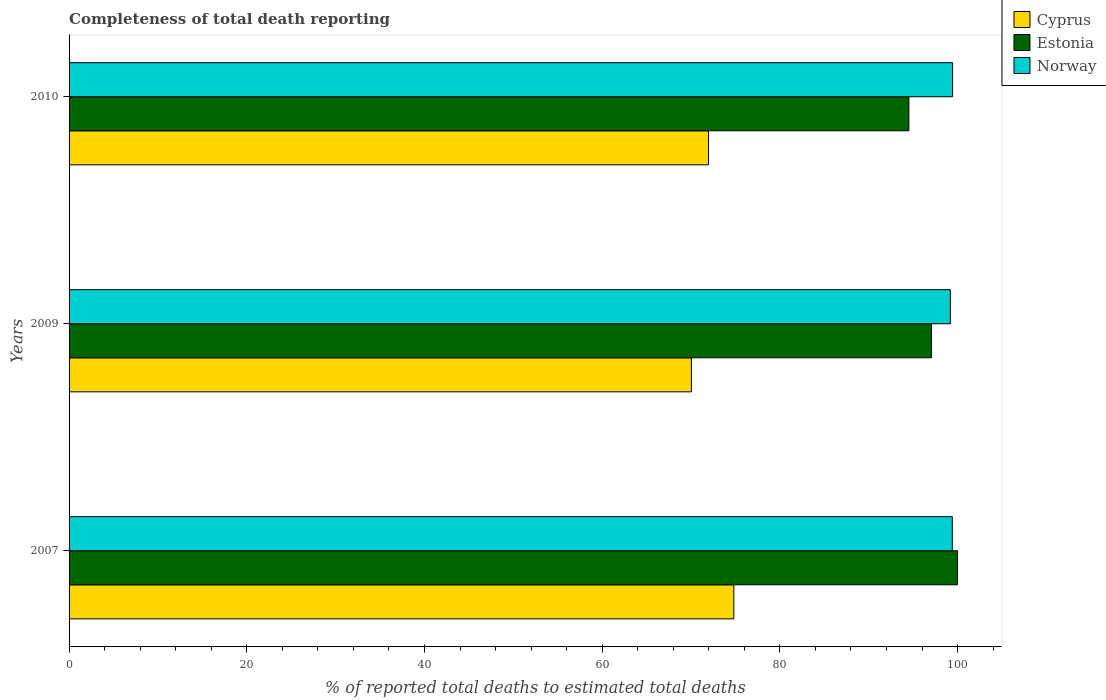How many groups of bars are there?
Your response must be concise. 3. In how many cases, is the number of bars for a given year not equal to the number of legend labels?
Keep it short and to the point. 0. What is the percentage of total deaths reported in Norway in 2010?
Give a very brief answer. 99.44. Across all years, what is the maximum percentage of total deaths reported in Estonia?
Your answer should be very brief. 100. Across all years, what is the minimum percentage of total deaths reported in Norway?
Offer a terse response. 99.19. In which year was the percentage of total deaths reported in Cyprus maximum?
Your response must be concise. 2007. In which year was the percentage of total deaths reported in Norway minimum?
Make the answer very short. 2009. What is the total percentage of total deaths reported in Norway in the graph?
Keep it short and to the point. 298.04. What is the difference between the percentage of total deaths reported in Estonia in 2007 and that in 2009?
Your answer should be very brief. 2.94. What is the difference between the percentage of total deaths reported in Cyprus in 2010 and the percentage of total deaths reported in Estonia in 2007?
Your response must be concise. -28.03. What is the average percentage of total deaths reported in Estonia per year?
Offer a terse response. 97.19. In the year 2007, what is the difference between the percentage of total deaths reported in Norway and percentage of total deaths reported in Estonia?
Ensure brevity in your answer.  -0.59. What is the ratio of the percentage of total deaths reported in Estonia in 2007 to that in 2010?
Make the answer very short. 1.06. Is the percentage of total deaths reported in Norway in 2007 less than that in 2009?
Offer a very short reply. No. Is the difference between the percentage of total deaths reported in Norway in 2007 and 2009 greater than the difference between the percentage of total deaths reported in Estonia in 2007 and 2009?
Provide a short and direct response. No. What is the difference between the highest and the second highest percentage of total deaths reported in Norway?
Provide a short and direct response. 0.03. What is the difference between the highest and the lowest percentage of total deaths reported in Norway?
Ensure brevity in your answer.  0.25. What does the 3rd bar from the top in 2009 represents?
Provide a short and direct response. Cyprus. What does the 1st bar from the bottom in 2009 represents?
Make the answer very short. Cyprus. Is it the case that in every year, the sum of the percentage of total deaths reported in Norway and percentage of total deaths reported in Cyprus is greater than the percentage of total deaths reported in Estonia?
Keep it short and to the point. Yes. How many bars are there?
Keep it short and to the point. 9. Are all the bars in the graph horizontal?
Your response must be concise. Yes. How many years are there in the graph?
Give a very brief answer. 3. What is the difference between two consecutive major ticks on the X-axis?
Your answer should be compact. 20. Does the graph contain any zero values?
Your answer should be very brief. No. Where does the legend appear in the graph?
Give a very brief answer. Top right. What is the title of the graph?
Provide a short and direct response. Completeness of total death reporting. What is the label or title of the X-axis?
Ensure brevity in your answer.  % of reported total deaths to estimated total deaths. What is the % of reported total deaths to estimated total deaths of Cyprus in 2007?
Provide a succinct answer. 74.82. What is the % of reported total deaths to estimated total deaths in Norway in 2007?
Your answer should be very brief. 99.41. What is the % of reported total deaths to estimated total deaths of Cyprus in 2009?
Ensure brevity in your answer.  70.05. What is the % of reported total deaths to estimated total deaths in Estonia in 2009?
Offer a very short reply. 97.06. What is the % of reported total deaths to estimated total deaths of Norway in 2009?
Provide a short and direct response. 99.19. What is the % of reported total deaths to estimated total deaths of Cyprus in 2010?
Provide a succinct answer. 71.97. What is the % of reported total deaths to estimated total deaths of Estonia in 2010?
Offer a terse response. 94.52. What is the % of reported total deaths to estimated total deaths of Norway in 2010?
Provide a short and direct response. 99.44. Across all years, what is the maximum % of reported total deaths to estimated total deaths of Cyprus?
Provide a succinct answer. 74.82. Across all years, what is the maximum % of reported total deaths to estimated total deaths in Norway?
Offer a very short reply. 99.44. Across all years, what is the minimum % of reported total deaths to estimated total deaths of Cyprus?
Provide a succinct answer. 70.05. Across all years, what is the minimum % of reported total deaths to estimated total deaths in Estonia?
Offer a very short reply. 94.52. Across all years, what is the minimum % of reported total deaths to estimated total deaths of Norway?
Provide a short and direct response. 99.19. What is the total % of reported total deaths to estimated total deaths of Cyprus in the graph?
Your answer should be compact. 216.84. What is the total % of reported total deaths to estimated total deaths of Estonia in the graph?
Provide a short and direct response. 291.58. What is the total % of reported total deaths to estimated total deaths of Norway in the graph?
Your answer should be very brief. 298.04. What is the difference between the % of reported total deaths to estimated total deaths in Cyprus in 2007 and that in 2009?
Keep it short and to the point. 4.78. What is the difference between the % of reported total deaths to estimated total deaths of Estonia in 2007 and that in 2009?
Your answer should be compact. 2.94. What is the difference between the % of reported total deaths to estimated total deaths of Norway in 2007 and that in 2009?
Give a very brief answer. 0.22. What is the difference between the % of reported total deaths to estimated total deaths in Cyprus in 2007 and that in 2010?
Your response must be concise. 2.85. What is the difference between the % of reported total deaths to estimated total deaths in Estonia in 2007 and that in 2010?
Make the answer very short. 5.48. What is the difference between the % of reported total deaths to estimated total deaths of Norway in 2007 and that in 2010?
Provide a succinct answer. -0.03. What is the difference between the % of reported total deaths to estimated total deaths in Cyprus in 2009 and that in 2010?
Ensure brevity in your answer.  -1.92. What is the difference between the % of reported total deaths to estimated total deaths of Estonia in 2009 and that in 2010?
Offer a terse response. 2.54. What is the difference between the % of reported total deaths to estimated total deaths in Norway in 2009 and that in 2010?
Provide a short and direct response. -0.25. What is the difference between the % of reported total deaths to estimated total deaths in Cyprus in 2007 and the % of reported total deaths to estimated total deaths in Estonia in 2009?
Offer a terse response. -22.24. What is the difference between the % of reported total deaths to estimated total deaths of Cyprus in 2007 and the % of reported total deaths to estimated total deaths of Norway in 2009?
Your answer should be compact. -24.37. What is the difference between the % of reported total deaths to estimated total deaths of Estonia in 2007 and the % of reported total deaths to estimated total deaths of Norway in 2009?
Provide a succinct answer. 0.81. What is the difference between the % of reported total deaths to estimated total deaths in Cyprus in 2007 and the % of reported total deaths to estimated total deaths in Estonia in 2010?
Your answer should be compact. -19.7. What is the difference between the % of reported total deaths to estimated total deaths in Cyprus in 2007 and the % of reported total deaths to estimated total deaths in Norway in 2010?
Offer a very short reply. -24.62. What is the difference between the % of reported total deaths to estimated total deaths in Estonia in 2007 and the % of reported total deaths to estimated total deaths in Norway in 2010?
Offer a very short reply. 0.56. What is the difference between the % of reported total deaths to estimated total deaths of Cyprus in 2009 and the % of reported total deaths to estimated total deaths of Estonia in 2010?
Offer a terse response. -24.48. What is the difference between the % of reported total deaths to estimated total deaths in Cyprus in 2009 and the % of reported total deaths to estimated total deaths in Norway in 2010?
Your response must be concise. -29.39. What is the difference between the % of reported total deaths to estimated total deaths in Estonia in 2009 and the % of reported total deaths to estimated total deaths in Norway in 2010?
Make the answer very short. -2.38. What is the average % of reported total deaths to estimated total deaths of Cyprus per year?
Keep it short and to the point. 72.28. What is the average % of reported total deaths to estimated total deaths of Estonia per year?
Your response must be concise. 97.19. What is the average % of reported total deaths to estimated total deaths of Norway per year?
Offer a very short reply. 99.35. In the year 2007, what is the difference between the % of reported total deaths to estimated total deaths in Cyprus and % of reported total deaths to estimated total deaths in Estonia?
Your answer should be compact. -25.18. In the year 2007, what is the difference between the % of reported total deaths to estimated total deaths of Cyprus and % of reported total deaths to estimated total deaths of Norway?
Offer a terse response. -24.59. In the year 2007, what is the difference between the % of reported total deaths to estimated total deaths in Estonia and % of reported total deaths to estimated total deaths in Norway?
Give a very brief answer. 0.59. In the year 2009, what is the difference between the % of reported total deaths to estimated total deaths of Cyprus and % of reported total deaths to estimated total deaths of Estonia?
Your response must be concise. -27.01. In the year 2009, what is the difference between the % of reported total deaths to estimated total deaths in Cyprus and % of reported total deaths to estimated total deaths in Norway?
Your answer should be very brief. -29.14. In the year 2009, what is the difference between the % of reported total deaths to estimated total deaths in Estonia and % of reported total deaths to estimated total deaths in Norway?
Ensure brevity in your answer.  -2.13. In the year 2010, what is the difference between the % of reported total deaths to estimated total deaths in Cyprus and % of reported total deaths to estimated total deaths in Estonia?
Make the answer very short. -22.55. In the year 2010, what is the difference between the % of reported total deaths to estimated total deaths in Cyprus and % of reported total deaths to estimated total deaths in Norway?
Your answer should be compact. -27.47. In the year 2010, what is the difference between the % of reported total deaths to estimated total deaths of Estonia and % of reported total deaths to estimated total deaths of Norway?
Your response must be concise. -4.92. What is the ratio of the % of reported total deaths to estimated total deaths of Cyprus in 2007 to that in 2009?
Provide a succinct answer. 1.07. What is the ratio of the % of reported total deaths to estimated total deaths in Estonia in 2007 to that in 2009?
Ensure brevity in your answer.  1.03. What is the ratio of the % of reported total deaths to estimated total deaths of Cyprus in 2007 to that in 2010?
Make the answer very short. 1.04. What is the ratio of the % of reported total deaths to estimated total deaths of Estonia in 2007 to that in 2010?
Keep it short and to the point. 1.06. What is the ratio of the % of reported total deaths to estimated total deaths in Norway in 2007 to that in 2010?
Offer a terse response. 1. What is the ratio of the % of reported total deaths to estimated total deaths of Cyprus in 2009 to that in 2010?
Make the answer very short. 0.97. What is the ratio of the % of reported total deaths to estimated total deaths of Estonia in 2009 to that in 2010?
Provide a short and direct response. 1.03. What is the ratio of the % of reported total deaths to estimated total deaths in Norway in 2009 to that in 2010?
Offer a terse response. 1. What is the difference between the highest and the second highest % of reported total deaths to estimated total deaths in Cyprus?
Provide a succinct answer. 2.85. What is the difference between the highest and the second highest % of reported total deaths to estimated total deaths in Estonia?
Offer a very short reply. 2.94. What is the difference between the highest and the second highest % of reported total deaths to estimated total deaths in Norway?
Make the answer very short. 0.03. What is the difference between the highest and the lowest % of reported total deaths to estimated total deaths of Cyprus?
Provide a succinct answer. 4.78. What is the difference between the highest and the lowest % of reported total deaths to estimated total deaths of Estonia?
Provide a succinct answer. 5.48. What is the difference between the highest and the lowest % of reported total deaths to estimated total deaths in Norway?
Make the answer very short. 0.25. 